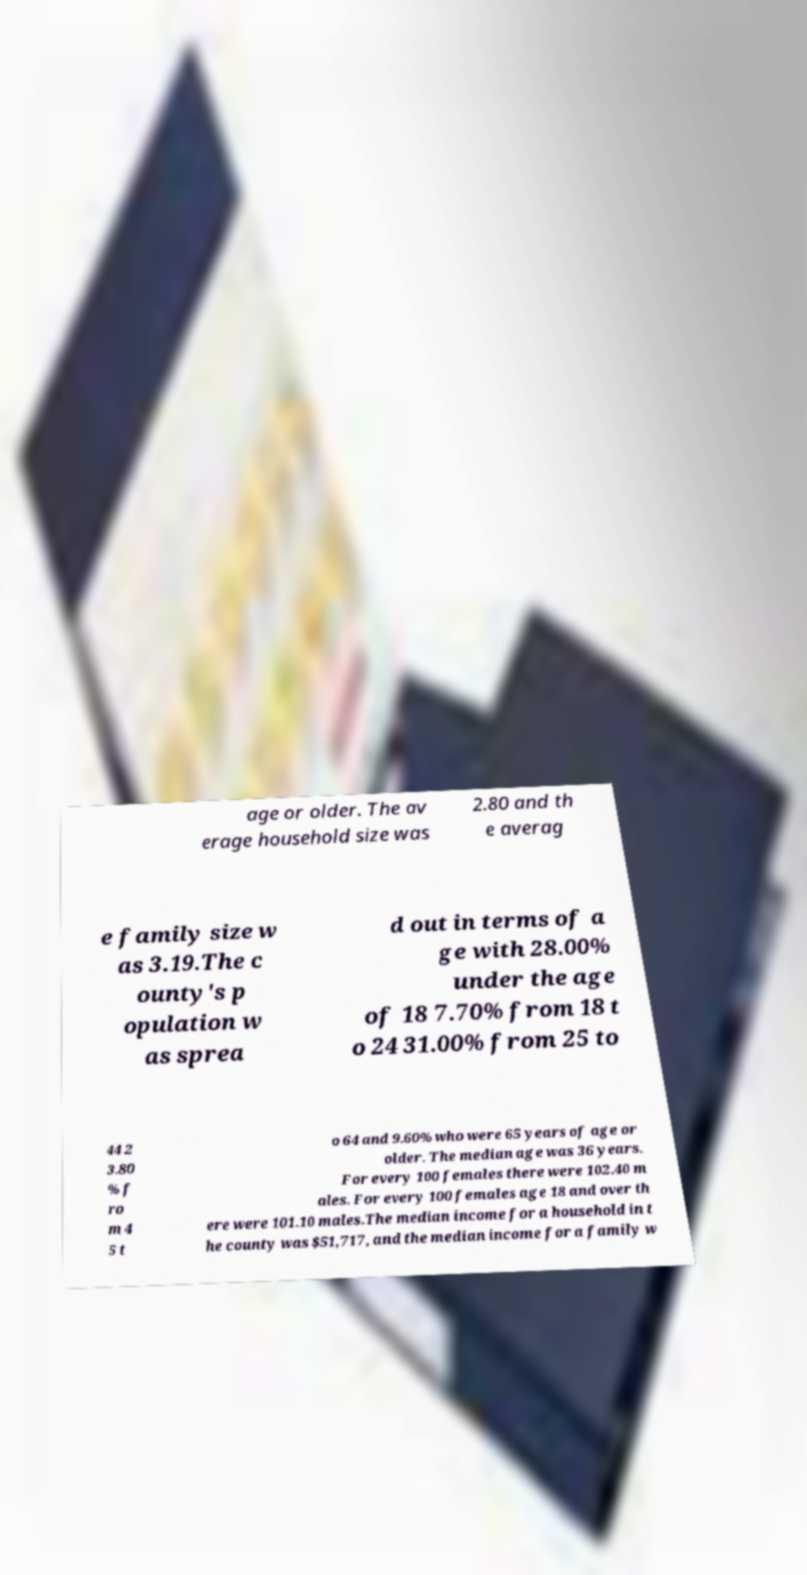What messages or text are displayed in this image? I need them in a readable, typed format. age or older. The av erage household size was 2.80 and th e averag e family size w as 3.19.The c ounty's p opulation w as sprea d out in terms of a ge with 28.00% under the age of 18 7.70% from 18 t o 24 31.00% from 25 to 44 2 3.80 % f ro m 4 5 t o 64 and 9.60% who were 65 years of age or older. The median age was 36 years. For every 100 females there were 102.40 m ales. For every 100 females age 18 and over th ere were 101.10 males.The median income for a household in t he county was $51,717, and the median income for a family w 